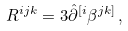Convert formula to latex. <formula><loc_0><loc_0><loc_500><loc_500>R ^ { i j k } = 3 \hat { \partial } ^ { [ i } \beta ^ { j k ] } \, ,</formula> 